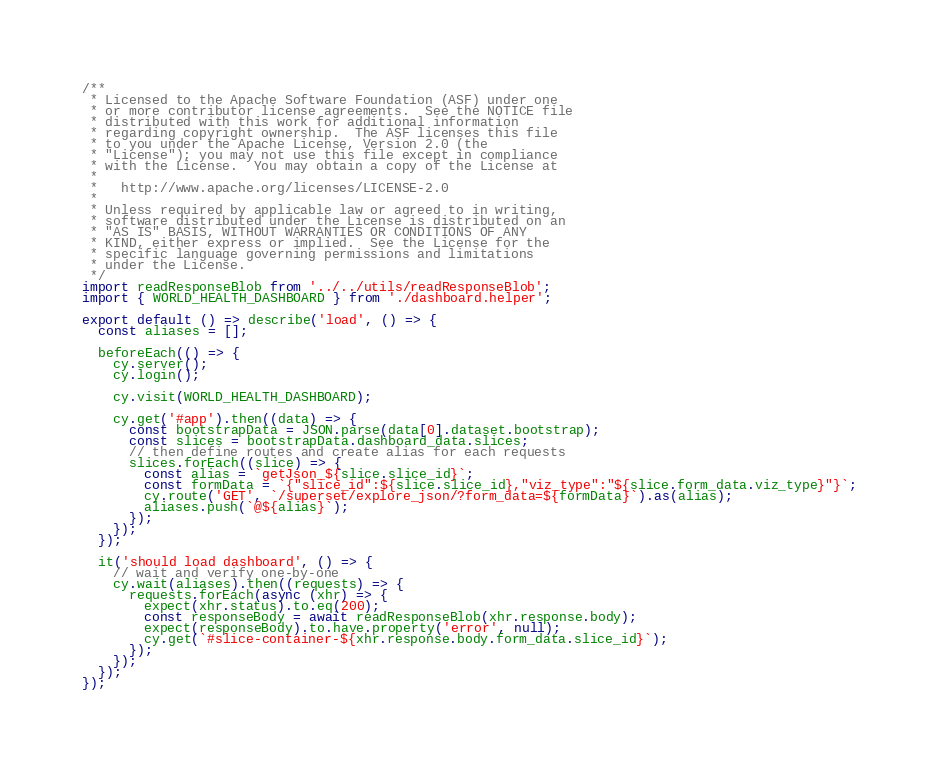<code> <loc_0><loc_0><loc_500><loc_500><_JavaScript_>/**
 * Licensed to the Apache Software Foundation (ASF) under one
 * or more contributor license agreements.  See the NOTICE file
 * distributed with this work for additional information
 * regarding copyright ownership.  The ASF licenses this file
 * to you under the Apache License, Version 2.0 (the
 * "License"); you may not use this file except in compliance
 * with the License.  You may obtain a copy of the License at
 *
 *   http://www.apache.org/licenses/LICENSE-2.0
 *
 * Unless required by applicable law or agreed to in writing,
 * software distributed under the License is distributed on an
 * "AS IS" BASIS, WITHOUT WARRANTIES OR CONDITIONS OF ANY
 * KIND, either express or implied.  See the License for the
 * specific language governing permissions and limitations
 * under the License.
 */
import readResponseBlob from '../../utils/readResponseBlob';
import { WORLD_HEALTH_DASHBOARD } from './dashboard.helper';

export default () => describe('load', () => {
  const aliases = [];

  beforeEach(() => {
    cy.server();
    cy.login();

    cy.visit(WORLD_HEALTH_DASHBOARD);

    cy.get('#app').then((data) => {
      const bootstrapData = JSON.parse(data[0].dataset.bootstrap);
      const slices = bootstrapData.dashboard_data.slices;
      // then define routes and create alias for each requests
      slices.forEach((slice) => {
        const alias = `getJson_${slice.slice_id}`;
        const formData = `{"slice_id":${slice.slice_id},"viz_type":"${slice.form_data.viz_type}"}`;
        cy.route('GET', `/superset/explore_json/?form_data=${formData}`).as(alias);
        aliases.push(`@${alias}`);
      });
    });
  });

  it('should load dashboard', () => {
    // wait and verify one-by-one
    cy.wait(aliases).then((requests) => {
      requests.forEach(async (xhr) => {
        expect(xhr.status).to.eq(200);
        const responseBody = await readResponseBlob(xhr.response.body);
        expect(responseBody).to.have.property('error', null);
        cy.get(`#slice-container-${xhr.response.body.form_data.slice_id}`);
      });
    });
  });
});
</code> 